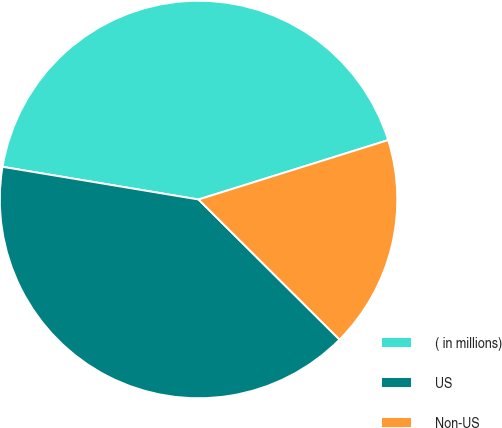Convert chart to OTSL. <chart><loc_0><loc_0><loc_500><loc_500><pie_chart><fcel>( in millions)<fcel>US<fcel>Non-US<nl><fcel>42.54%<fcel>40.18%<fcel>17.28%<nl></chart> 